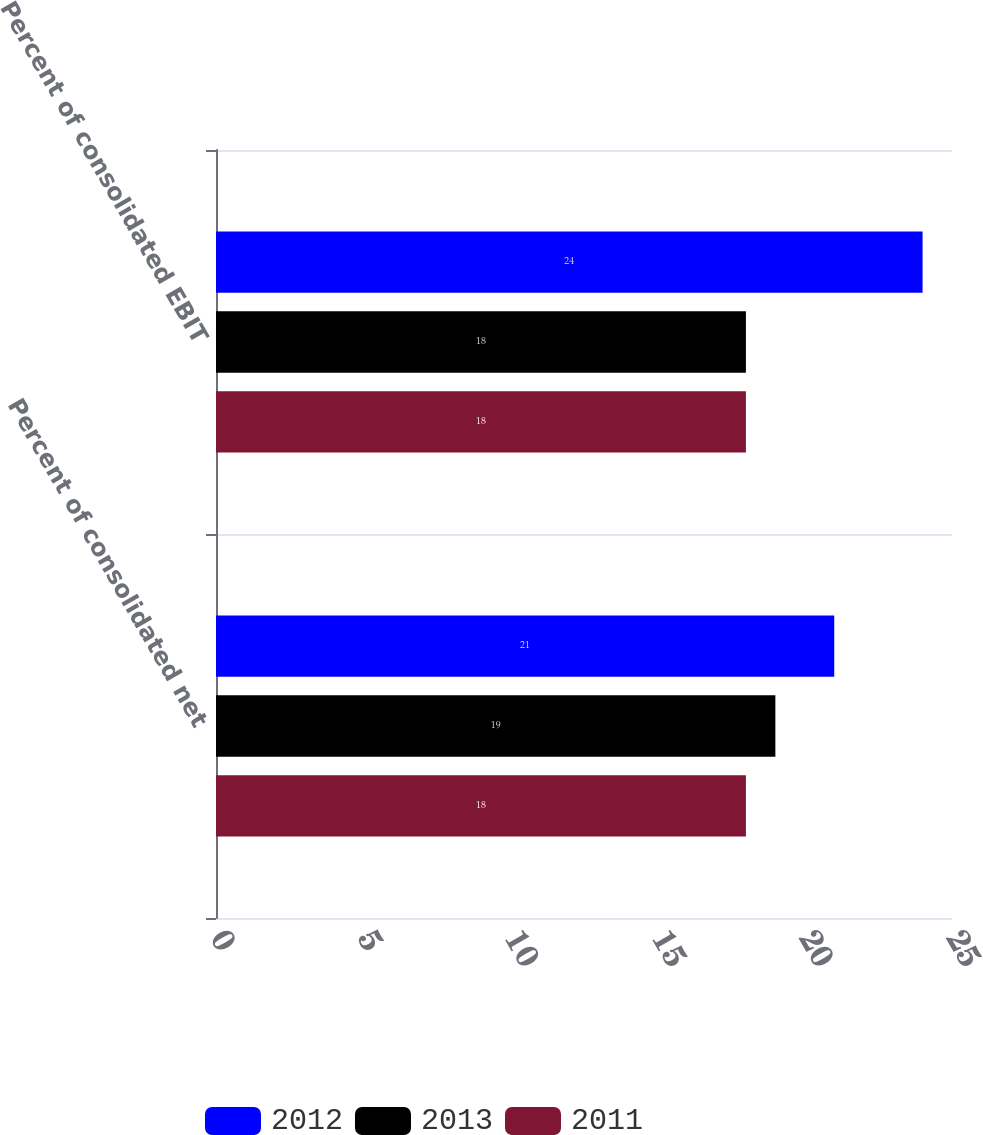Convert chart. <chart><loc_0><loc_0><loc_500><loc_500><stacked_bar_chart><ecel><fcel>Percent of consolidated net<fcel>Percent of consolidated EBIT<nl><fcel>2012<fcel>21<fcel>24<nl><fcel>2013<fcel>19<fcel>18<nl><fcel>2011<fcel>18<fcel>18<nl></chart> 